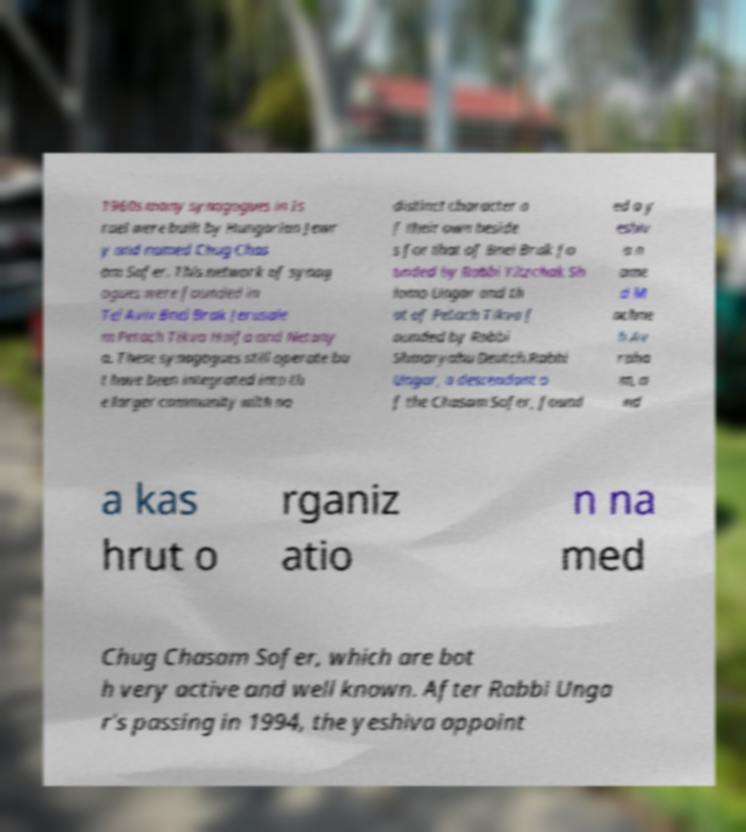Could you assist in decoding the text presented in this image and type it out clearly? 1960s many synagogues in Is rael were built by Hungarian Jewr y and named Chug Chas am Sofer. This network of synag ogues were founded in Tel Aviv Bnei Brak Jerusale m Petach Tikva Haifa and Netany a. These synagogues still operate bu t have been integrated into th e larger community with no distinct character o f their own beside s for that of Bnei Brak fo unded by Rabbi Yitzchak Sh lomo Ungar and th at of Petach Tikva f ounded by Rabbi Shmaryahu Deutch.Rabbi Ungar, a descendant o f the Chasam Sofer, found ed a y eshiv a n ame d M achne h Av raha m, a nd a kas hrut o rganiz atio n na med Chug Chasam Sofer, which are bot h very active and well known. After Rabbi Unga r's passing in 1994, the yeshiva appoint 